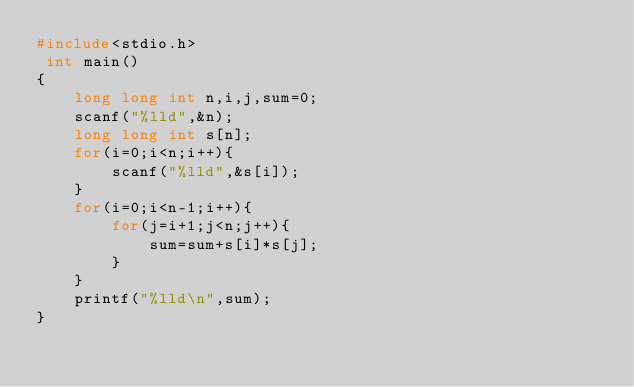Convert code to text. <code><loc_0><loc_0><loc_500><loc_500><_C_>#include<stdio.h>
 int main()
{
    long long int n,i,j,sum=0;
    scanf("%lld",&n);
    long long int s[n];
    for(i=0;i<n;i++){
        scanf("%lld",&s[i]);
    }
    for(i=0;i<n-1;i++){
        for(j=i+1;j<n;j++){
            sum=sum+s[i]*s[j];
        }
    }
    printf("%lld\n",sum);
}
</code> 